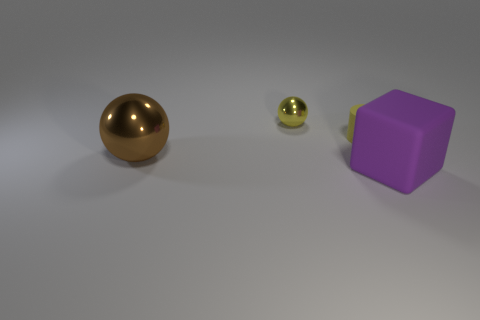Add 2 metallic objects. How many objects exist? 6 Subtract all cylinders. How many objects are left? 3 Add 3 big purple objects. How many big purple objects are left? 4 Add 2 blue shiny cubes. How many blue shiny cubes exist? 2 Subtract 0 blue cylinders. How many objects are left? 4 Subtract all cyan matte objects. Subtract all yellow things. How many objects are left? 2 